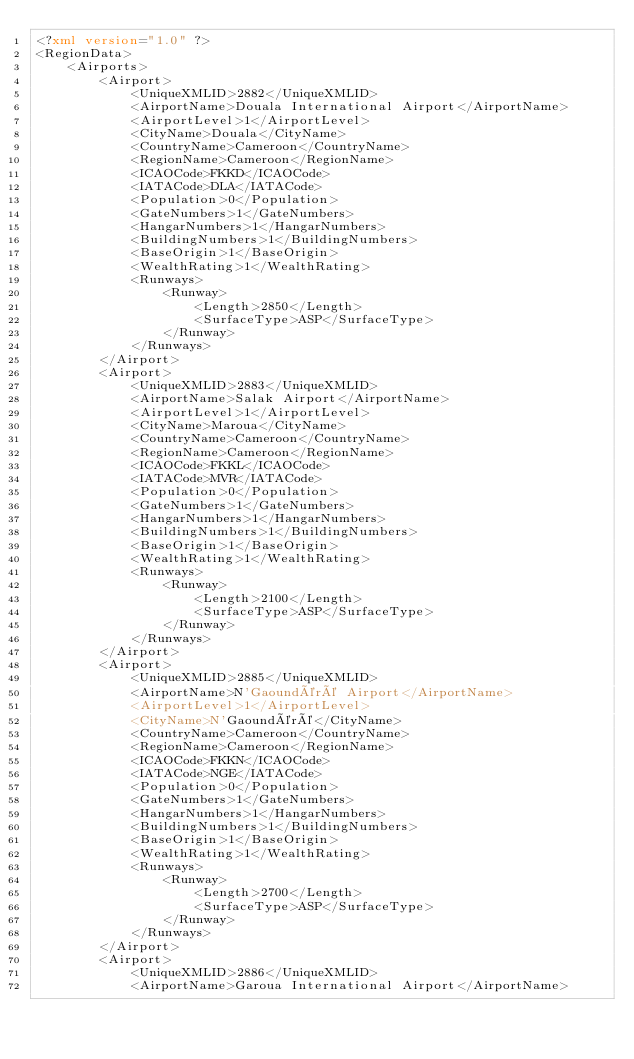Convert code to text. <code><loc_0><loc_0><loc_500><loc_500><_XML_><?xml version="1.0" ?>
<RegionData>
	<Airports>
		<Airport>
			<UniqueXMLID>2882</UniqueXMLID>
			<AirportName>Douala International Airport</AirportName>
			<AirportLevel>1</AirportLevel>
			<CityName>Douala</CityName>
			<CountryName>Cameroon</CountryName>
			<RegionName>Cameroon</RegionName>
			<ICAOCode>FKKD</ICAOCode>
			<IATACode>DLA</IATACode>
			<Population>0</Population>
			<GateNumbers>1</GateNumbers>
			<HangarNumbers>1</HangarNumbers>
			<BuildingNumbers>1</BuildingNumbers>
			<BaseOrigin>1</BaseOrigin>
			<WealthRating>1</WealthRating>
			<Runways>
				<Runway>
					<Length>2850</Length>
					<SurfaceType>ASP</SurfaceType>
				</Runway>
			</Runways>
		</Airport>
		<Airport>
			<UniqueXMLID>2883</UniqueXMLID>
			<AirportName>Salak Airport</AirportName>
			<AirportLevel>1</AirportLevel>
			<CityName>Maroua</CityName>
			<CountryName>Cameroon</CountryName>
			<RegionName>Cameroon</RegionName>
			<ICAOCode>FKKL</ICAOCode>
			<IATACode>MVR</IATACode>
			<Population>0</Population>
			<GateNumbers>1</GateNumbers>
			<HangarNumbers>1</HangarNumbers>
			<BuildingNumbers>1</BuildingNumbers>
			<BaseOrigin>1</BaseOrigin>
			<WealthRating>1</WealthRating>
			<Runways>
				<Runway>
					<Length>2100</Length>
					<SurfaceType>ASP</SurfaceType>
				</Runway>
			</Runways>
		</Airport>
		<Airport>
			<UniqueXMLID>2885</UniqueXMLID>
			<AirportName>N'Gaoundéré Airport</AirportName>
			<AirportLevel>1</AirportLevel>
			<CityName>N'Gaoundéré</CityName>
			<CountryName>Cameroon</CountryName>
			<RegionName>Cameroon</RegionName>
			<ICAOCode>FKKN</ICAOCode>
			<IATACode>NGE</IATACode>
			<Population>0</Population>
			<GateNumbers>1</GateNumbers>
			<HangarNumbers>1</HangarNumbers>
			<BuildingNumbers>1</BuildingNumbers>
			<BaseOrigin>1</BaseOrigin>
			<WealthRating>1</WealthRating>
			<Runways>
				<Runway>
					<Length>2700</Length>
					<SurfaceType>ASP</SurfaceType>
				</Runway>
			</Runways>
		</Airport>
		<Airport>
			<UniqueXMLID>2886</UniqueXMLID>
			<AirportName>Garoua International Airport</AirportName></code> 